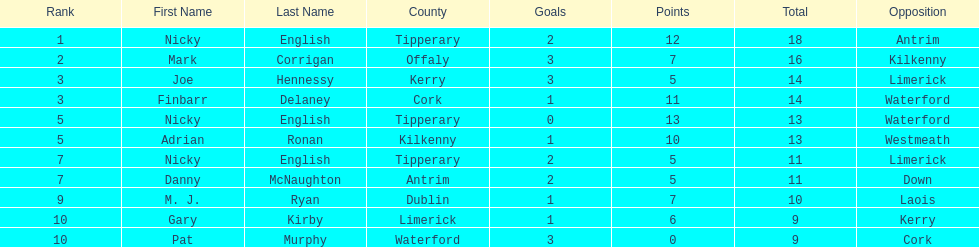What is the least total on the list? 9. 